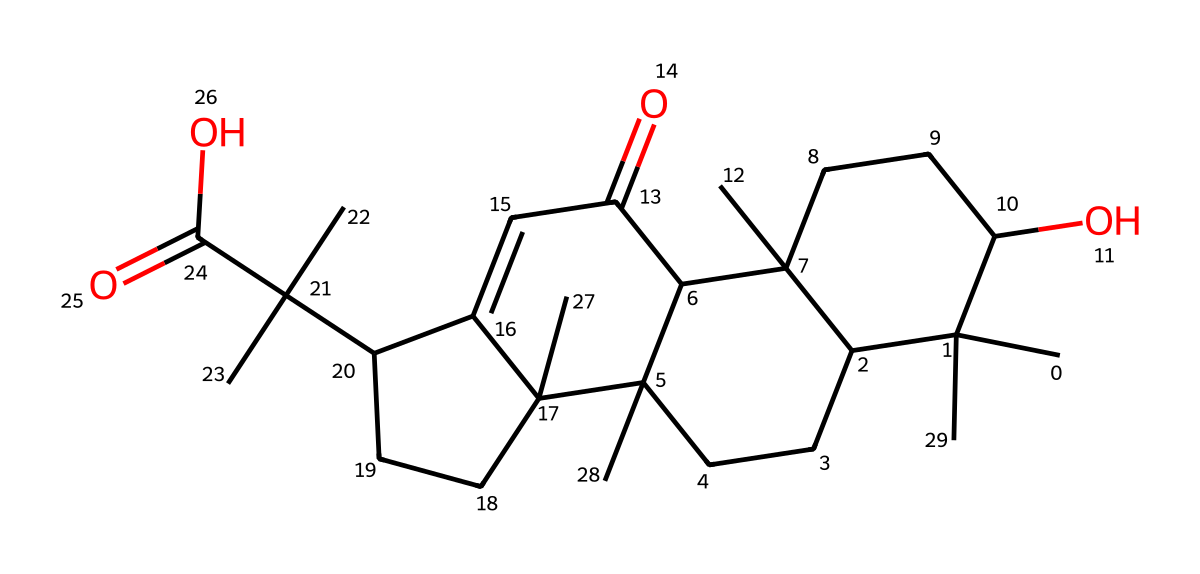how many carbon atoms are in the structure? By counting the number of carbon (C) symbols in the SMILES representation, we find there are 36 instances of carbon atoms indicated.
Answer: 36 what is the oxidation state of the molecule? The oxidation state is generally determined by the functional groups present; in this case, the presence of hydroxyl (-OH) and carbonyl (C=O) groups suggests a mix of oxidation states. Most carbons are in the +1 state with some potentially higher due to the functional groups, indicating a complex oxidation state that averages to +1 across the structure.
Answer: +1 which functional group is present at the end of the structure? The last part of the SMILES shows the presence of a carboxylic acid group, which is characterized by the -COOH functional group.
Answer: carboxylic acid is the molecule more likely to be hydrophilic or hydrophobic? The presence of hydroxyl (-OH) and carboxylic acid (-COOH) groups indicates that the molecule is hydrophilic due to its ability to form hydrogen bonds with water.
Answer: hydrophilic what type of molecular geometry do you expect for the central carbon atoms? The central carbon atoms in the cyclic and branched portions are typically tetrahedral due to sp3 hybridization, giving them a molecular geometry of tetrahedral.
Answer: tetrahedral which part of the molecule contributes to its aromatic qualities? The presence of cyclic carbon structures with alternating double bonds suggests that there are aromatic qualities, particularly in parts of the SMILES that indicate conjugated systems.
Answer: cyclic structures 